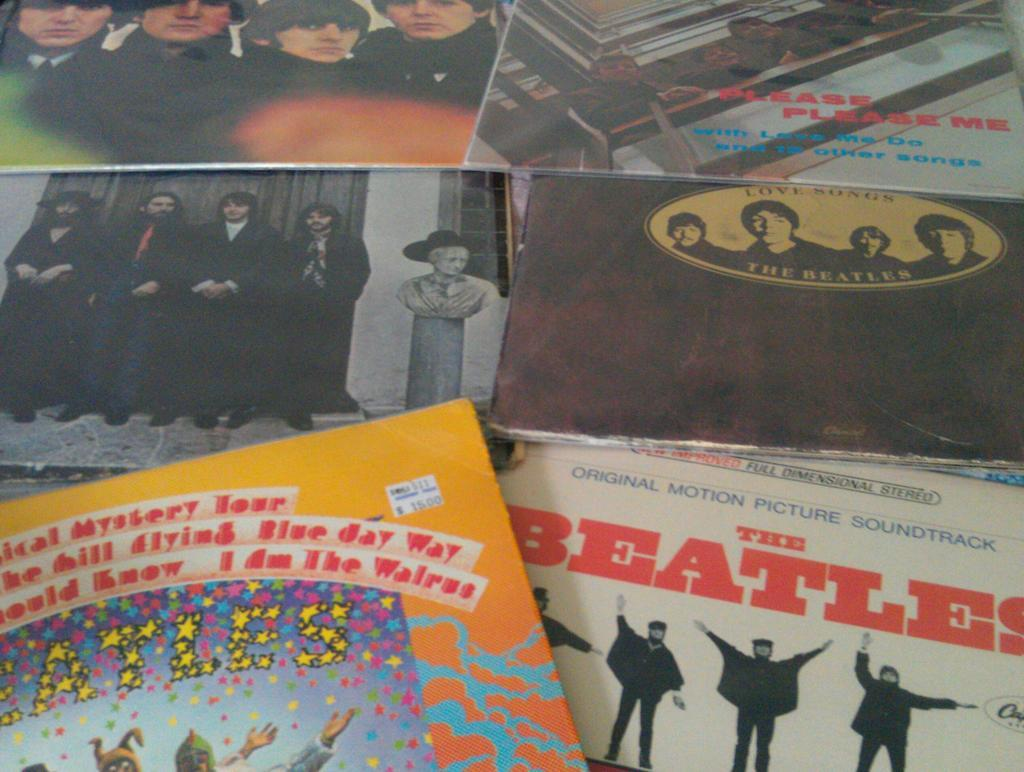<image>
Render a clear and concise summary of the photo. A collection of album covers from The Beatles records. 